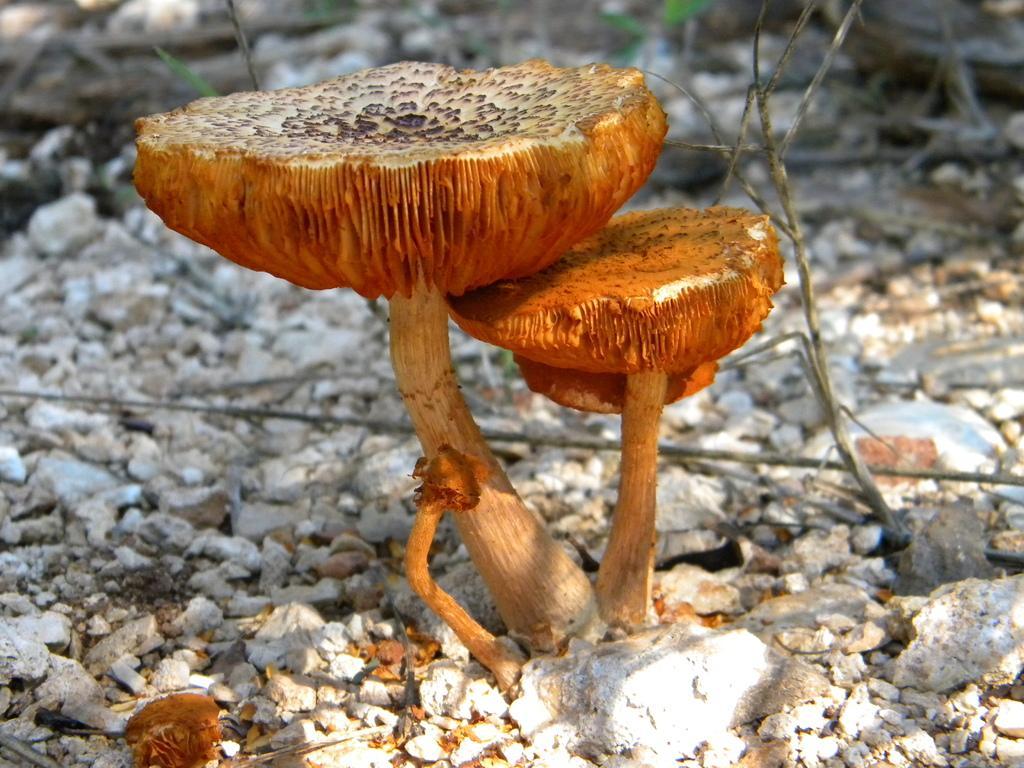Describe this image in one or two sentences. This picture is clicked outside. In the center there is a mushroom plant. In the background we can see the gravels and the stones. 